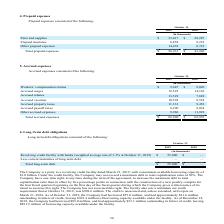From Sanderson Farms's financial document, What is the value of Parts and supplies for fiscal years 2019 and 2018 respectively? The document shows two values: $33,617 and $28,287 (in thousands). From the document: "Parts and supplies $ 33,617 $ 28,287 Parts and supplies $ 33,617 $ 28,287..." Also, What is the value of Prepaid insurance for fiscal years 2019 and 2018 respectively? The document shows two values: 8,859 and 8,232 (in thousands). From the document: "Prepaid insurance 8,859 8,232 Prepaid insurance 8,859 8,232..." Also, What does the table contain data about? According to the financial document, Prepaid expenses. The relevant text states: "4. Prepaid expenses..." Also, can you calculate: What is the average Parts and supplies for fiscal years 2019 and 2018? To answer this question, I need to perform calculations using the financial data. The calculation is: (33,617+ 28,287)/2, which equals 30952 (in thousands). This is based on the information: "Parts and supplies $ 33,617 $ 28,287 Parts and supplies $ 33,617 $ 28,287..." The key data points involved are: 28,287, 33,617. Also, can you calculate: What is the average Prepaid insurance for fiscal years 2019 and 2018? To answer this question, I need to perform calculations using the financial data. The calculation is: (8,859+ 8,232)/2, which equals 8545.5 (in thousands). This is based on the information: "Prepaid insurance 8,859 8,232 Prepaid insurance 8,859 8,232..." The key data points involved are: 8,232, 8,859. Also, can you calculate: What is the change in Total prepaid expenses between fiscal years 2019 and 2018? Based on the calculation: 56,931-43,240, the result is 13691 (in thousands). This is based on the information: "Total prepaid expenses $ 56,931 $ 43,240 Total prepaid expenses $ 56,931 $ 43,240..." The key data points involved are: 43,240, 56,931. 